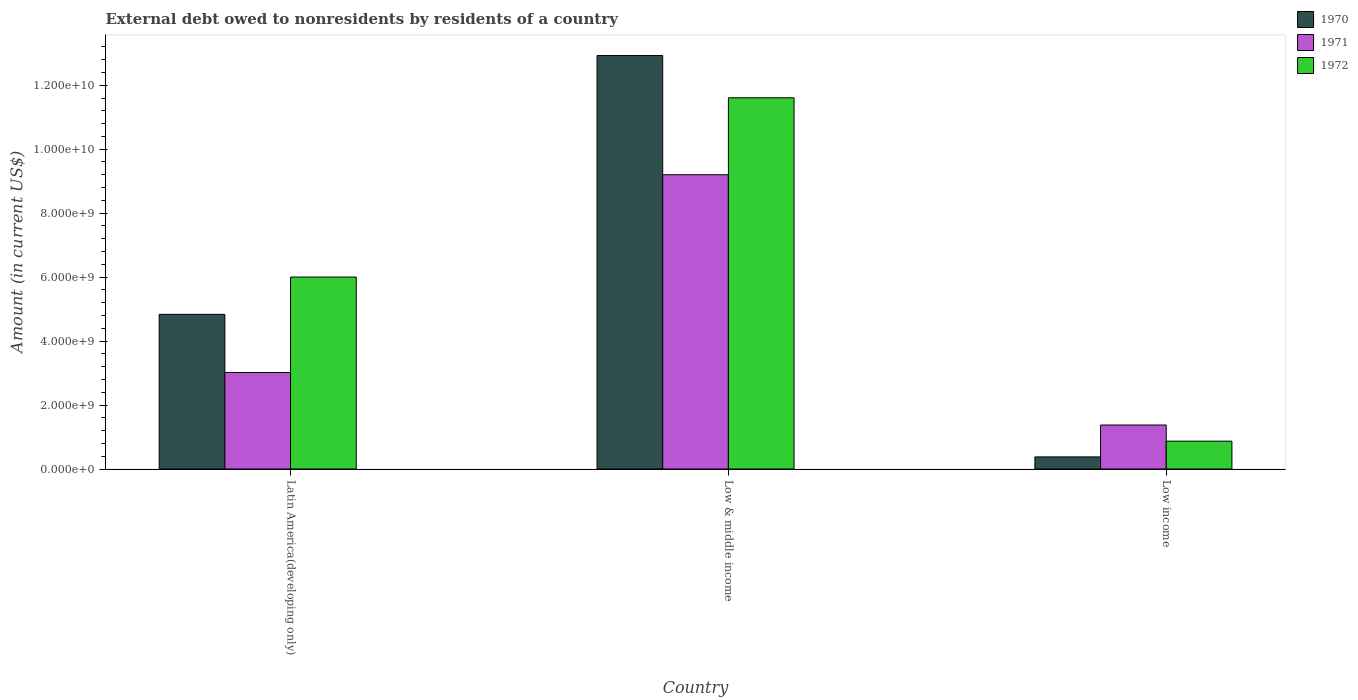How many different coloured bars are there?
Give a very brief answer. 3. Are the number of bars per tick equal to the number of legend labels?
Provide a succinct answer. Yes. How many bars are there on the 1st tick from the left?
Offer a very short reply. 3. What is the label of the 3rd group of bars from the left?
Make the answer very short. Low income. In how many cases, is the number of bars for a given country not equal to the number of legend labels?
Your answer should be very brief. 0. What is the external debt owed by residents in 1971 in Low income?
Offer a very short reply. 1.38e+09. Across all countries, what is the maximum external debt owed by residents in 1970?
Your answer should be very brief. 1.29e+1. Across all countries, what is the minimum external debt owed by residents in 1972?
Give a very brief answer. 8.71e+08. In which country was the external debt owed by residents in 1971 minimum?
Make the answer very short. Low income. What is the total external debt owed by residents in 1970 in the graph?
Your response must be concise. 1.81e+1. What is the difference between the external debt owed by residents in 1971 in Latin America(developing only) and that in Low & middle income?
Keep it short and to the point. -6.18e+09. What is the difference between the external debt owed by residents in 1970 in Low income and the external debt owed by residents in 1971 in Latin America(developing only)?
Offer a terse response. -2.64e+09. What is the average external debt owed by residents in 1972 per country?
Your answer should be very brief. 6.16e+09. What is the difference between the external debt owed by residents of/in 1972 and external debt owed by residents of/in 1970 in Latin America(developing only)?
Your response must be concise. 1.17e+09. What is the ratio of the external debt owed by residents in 1971 in Latin America(developing only) to that in Low income?
Your answer should be compact. 2.19. Is the external debt owed by residents in 1971 in Latin America(developing only) less than that in Low income?
Provide a succinct answer. No. What is the difference between the highest and the second highest external debt owed by residents in 1970?
Your answer should be very brief. 4.46e+09. What is the difference between the highest and the lowest external debt owed by residents in 1970?
Give a very brief answer. 1.25e+1. In how many countries, is the external debt owed by residents in 1970 greater than the average external debt owed by residents in 1970 taken over all countries?
Give a very brief answer. 1. How many bars are there?
Offer a very short reply. 9. Are all the bars in the graph horizontal?
Provide a short and direct response. No. What is the difference between two consecutive major ticks on the Y-axis?
Your response must be concise. 2.00e+09. Are the values on the major ticks of Y-axis written in scientific E-notation?
Keep it short and to the point. Yes. Does the graph contain any zero values?
Provide a succinct answer. No. Where does the legend appear in the graph?
Keep it short and to the point. Top right. How many legend labels are there?
Ensure brevity in your answer.  3. How are the legend labels stacked?
Your response must be concise. Vertical. What is the title of the graph?
Provide a short and direct response. External debt owed to nonresidents by residents of a country. What is the label or title of the Y-axis?
Your answer should be compact. Amount (in current US$). What is the Amount (in current US$) in 1970 in Latin America(developing only)?
Make the answer very short. 4.84e+09. What is the Amount (in current US$) in 1971 in Latin America(developing only)?
Offer a very short reply. 3.02e+09. What is the Amount (in current US$) in 1972 in Latin America(developing only)?
Make the answer very short. 6.00e+09. What is the Amount (in current US$) in 1970 in Low & middle income?
Make the answer very short. 1.29e+1. What is the Amount (in current US$) in 1971 in Low & middle income?
Offer a terse response. 9.20e+09. What is the Amount (in current US$) in 1972 in Low & middle income?
Offer a terse response. 1.16e+1. What is the Amount (in current US$) of 1970 in Low income?
Your answer should be compact. 3.78e+08. What is the Amount (in current US$) of 1971 in Low income?
Offer a terse response. 1.38e+09. What is the Amount (in current US$) in 1972 in Low income?
Offer a terse response. 8.71e+08. Across all countries, what is the maximum Amount (in current US$) in 1970?
Provide a succinct answer. 1.29e+1. Across all countries, what is the maximum Amount (in current US$) in 1971?
Offer a very short reply. 9.20e+09. Across all countries, what is the maximum Amount (in current US$) of 1972?
Your answer should be very brief. 1.16e+1. Across all countries, what is the minimum Amount (in current US$) of 1970?
Offer a very short reply. 3.78e+08. Across all countries, what is the minimum Amount (in current US$) of 1971?
Your response must be concise. 1.38e+09. Across all countries, what is the minimum Amount (in current US$) of 1972?
Your response must be concise. 8.71e+08. What is the total Amount (in current US$) in 1970 in the graph?
Your answer should be very brief. 1.81e+1. What is the total Amount (in current US$) in 1971 in the graph?
Give a very brief answer. 1.36e+1. What is the total Amount (in current US$) of 1972 in the graph?
Give a very brief answer. 1.85e+1. What is the difference between the Amount (in current US$) in 1970 in Latin America(developing only) and that in Low & middle income?
Offer a very short reply. -8.09e+09. What is the difference between the Amount (in current US$) in 1971 in Latin America(developing only) and that in Low & middle income?
Provide a short and direct response. -6.18e+09. What is the difference between the Amount (in current US$) in 1972 in Latin America(developing only) and that in Low & middle income?
Provide a short and direct response. -5.61e+09. What is the difference between the Amount (in current US$) of 1970 in Latin America(developing only) and that in Low income?
Make the answer very short. 4.46e+09. What is the difference between the Amount (in current US$) of 1971 in Latin America(developing only) and that in Low income?
Your answer should be very brief. 1.64e+09. What is the difference between the Amount (in current US$) in 1972 in Latin America(developing only) and that in Low income?
Ensure brevity in your answer.  5.13e+09. What is the difference between the Amount (in current US$) of 1970 in Low & middle income and that in Low income?
Offer a very short reply. 1.25e+1. What is the difference between the Amount (in current US$) in 1971 in Low & middle income and that in Low income?
Offer a terse response. 7.83e+09. What is the difference between the Amount (in current US$) in 1972 in Low & middle income and that in Low income?
Your answer should be compact. 1.07e+1. What is the difference between the Amount (in current US$) of 1970 in Latin America(developing only) and the Amount (in current US$) of 1971 in Low & middle income?
Offer a very short reply. -4.37e+09. What is the difference between the Amount (in current US$) of 1970 in Latin America(developing only) and the Amount (in current US$) of 1972 in Low & middle income?
Your answer should be very brief. -6.77e+09. What is the difference between the Amount (in current US$) of 1971 in Latin America(developing only) and the Amount (in current US$) of 1972 in Low & middle income?
Keep it short and to the point. -8.59e+09. What is the difference between the Amount (in current US$) of 1970 in Latin America(developing only) and the Amount (in current US$) of 1971 in Low income?
Give a very brief answer. 3.46e+09. What is the difference between the Amount (in current US$) of 1970 in Latin America(developing only) and the Amount (in current US$) of 1972 in Low income?
Your response must be concise. 3.97e+09. What is the difference between the Amount (in current US$) of 1971 in Latin America(developing only) and the Amount (in current US$) of 1972 in Low income?
Provide a short and direct response. 2.15e+09. What is the difference between the Amount (in current US$) in 1970 in Low & middle income and the Amount (in current US$) in 1971 in Low income?
Provide a short and direct response. 1.16e+1. What is the difference between the Amount (in current US$) in 1970 in Low & middle income and the Amount (in current US$) in 1972 in Low income?
Offer a terse response. 1.21e+1. What is the difference between the Amount (in current US$) of 1971 in Low & middle income and the Amount (in current US$) of 1972 in Low income?
Your response must be concise. 8.33e+09. What is the average Amount (in current US$) in 1970 per country?
Give a very brief answer. 6.05e+09. What is the average Amount (in current US$) of 1971 per country?
Your response must be concise. 4.53e+09. What is the average Amount (in current US$) of 1972 per country?
Your answer should be compact. 6.16e+09. What is the difference between the Amount (in current US$) in 1970 and Amount (in current US$) in 1971 in Latin America(developing only)?
Offer a very short reply. 1.82e+09. What is the difference between the Amount (in current US$) of 1970 and Amount (in current US$) of 1972 in Latin America(developing only)?
Provide a short and direct response. -1.17e+09. What is the difference between the Amount (in current US$) in 1971 and Amount (in current US$) in 1972 in Latin America(developing only)?
Provide a short and direct response. -2.98e+09. What is the difference between the Amount (in current US$) of 1970 and Amount (in current US$) of 1971 in Low & middle income?
Your answer should be very brief. 3.73e+09. What is the difference between the Amount (in current US$) in 1970 and Amount (in current US$) in 1972 in Low & middle income?
Provide a succinct answer. 1.32e+09. What is the difference between the Amount (in current US$) in 1971 and Amount (in current US$) in 1972 in Low & middle income?
Provide a short and direct response. -2.41e+09. What is the difference between the Amount (in current US$) of 1970 and Amount (in current US$) of 1971 in Low income?
Offer a very short reply. -9.97e+08. What is the difference between the Amount (in current US$) in 1970 and Amount (in current US$) in 1972 in Low income?
Your answer should be compact. -4.92e+08. What is the difference between the Amount (in current US$) of 1971 and Amount (in current US$) of 1972 in Low income?
Provide a short and direct response. 5.05e+08. What is the ratio of the Amount (in current US$) of 1970 in Latin America(developing only) to that in Low & middle income?
Provide a short and direct response. 0.37. What is the ratio of the Amount (in current US$) of 1971 in Latin America(developing only) to that in Low & middle income?
Keep it short and to the point. 0.33. What is the ratio of the Amount (in current US$) of 1972 in Latin America(developing only) to that in Low & middle income?
Your answer should be very brief. 0.52. What is the ratio of the Amount (in current US$) of 1970 in Latin America(developing only) to that in Low income?
Ensure brevity in your answer.  12.78. What is the ratio of the Amount (in current US$) in 1971 in Latin America(developing only) to that in Low income?
Offer a very short reply. 2.19. What is the ratio of the Amount (in current US$) of 1972 in Latin America(developing only) to that in Low income?
Provide a short and direct response. 6.89. What is the ratio of the Amount (in current US$) of 1970 in Low & middle income to that in Low income?
Your response must be concise. 34.16. What is the ratio of the Amount (in current US$) in 1971 in Low & middle income to that in Low income?
Ensure brevity in your answer.  6.69. What is the ratio of the Amount (in current US$) in 1972 in Low & middle income to that in Low income?
Your answer should be very brief. 13.33. What is the difference between the highest and the second highest Amount (in current US$) in 1970?
Your response must be concise. 8.09e+09. What is the difference between the highest and the second highest Amount (in current US$) of 1971?
Give a very brief answer. 6.18e+09. What is the difference between the highest and the second highest Amount (in current US$) in 1972?
Ensure brevity in your answer.  5.61e+09. What is the difference between the highest and the lowest Amount (in current US$) in 1970?
Give a very brief answer. 1.25e+1. What is the difference between the highest and the lowest Amount (in current US$) of 1971?
Provide a short and direct response. 7.83e+09. What is the difference between the highest and the lowest Amount (in current US$) in 1972?
Offer a terse response. 1.07e+1. 